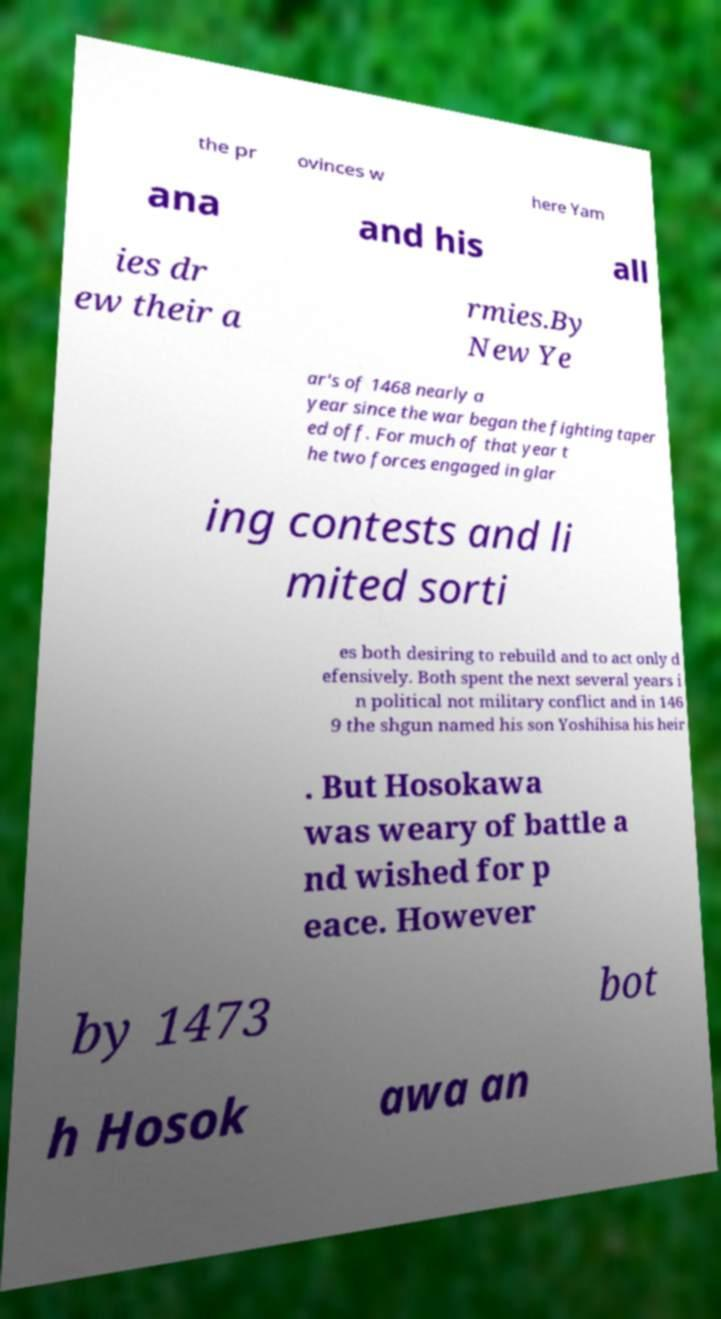What messages or text are displayed in this image? I need them in a readable, typed format. the pr ovinces w here Yam ana and his all ies dr ew their a rmies.By New Ye ar's of 1468 nearly a year since the war began the fighting taper ed off. For much of that year t he two forces engaged in glar ing contests and li mited sorti es both desiring to rebuild and to act only d efensively. Both spent the next several years i n political not military conflict and in 146 9 the shgun named his son Yoshihisa his heir . But Hosokawa was weary of battle a nd wished for p eace. However by 1473 bot h Hosok awa an 